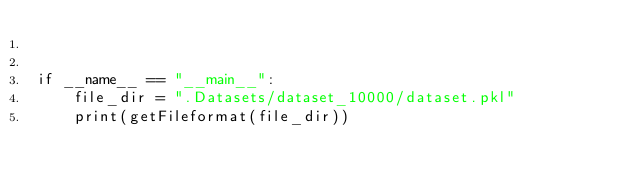Convert code to text. <code><loc_0><loc_0><loc_500><loc_500><_Python_>	
	
if __name__ == "__main__":
	file_dir = ".Datasets/dataset_10000/dataset.pkl"
	print(getFileformat(file_dir))
</code> 